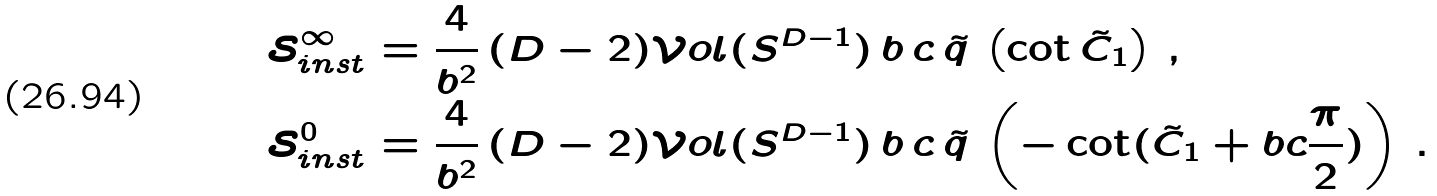Convert formula to latex. <formula><loc_0><loc_0><loc_500><loc_500>\mathcal { S } _ { i n s t } ^ { \infty } & = \frac { 4 } { b ^ { 2 } } \, ( D - 2 ) \mathcal { V } o l ( S ^ { D - 1 } ) \, { b \, c } \, \tilde { q } \, \left ( \cot \tilde { C } _ { 1 } \right ) \, , \\ \mathcal { S } _ { i n s t } ^ { 0 } & = \frac { 4 } { b ^ { 2 } } \, ( D - 2 ) \mathcal { V } o l ( S ^ { D - 1 } ) \, { b \, c } \, \tilde { q } \, \left ( - \cot ( \tilde { C } _ { 1 } + b c \frac { \pi } { 2 } ) \right ) \, .</formula> 